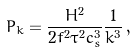<formula> <loc_0><loc_0><loc_500><loc_500>P _ { k } = \frac { H ^ { 2 } } { 2 f ^ { 2 } \tau ^ { 2 } c _ { s } ^ { 3 } } \frac { 1 } { k ^ { 3 } } \, ,</formula> 